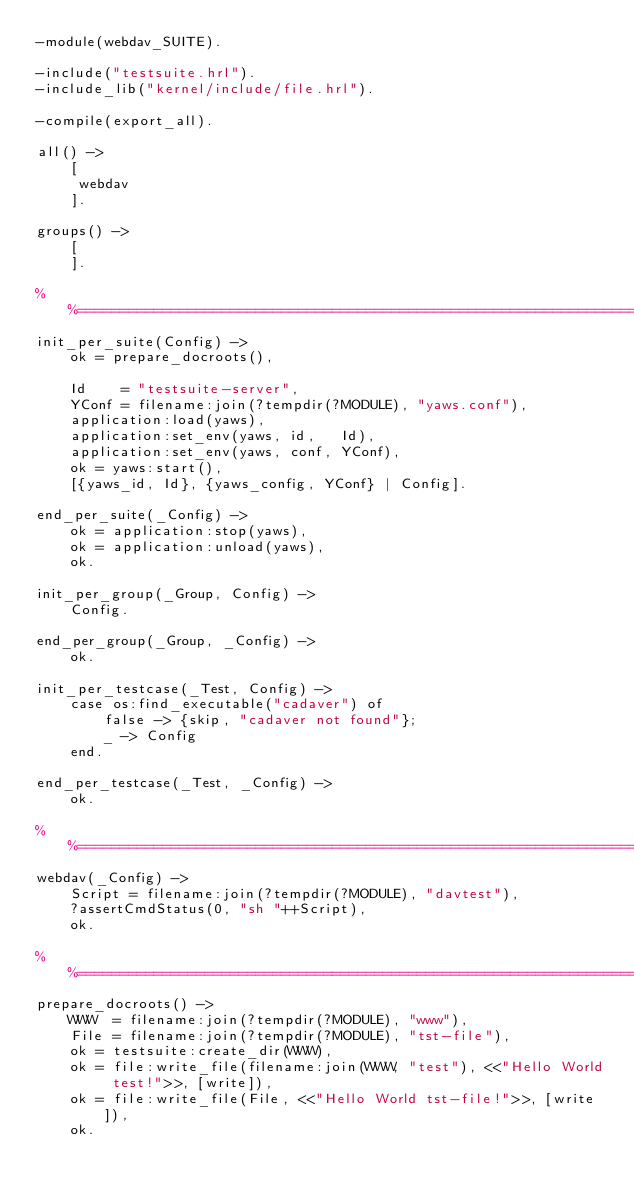Convert code to text. <code><loc_0><loc_0><loc_500><loc_500><_Erlang_>-module(webdav_SUITE).

-include("testsuite.hrl").
-include_lib("kernel/include/file.hrl").

-compile(export_all).

all() ->
    [
     webdav
    ].

groups() ->
    [
    ].

%%====================================================================
init_per_suite(Config) ->
    ok = prepare_docroots(),

    Id    = "testsuite-server",
    YConf = filename:join(?tempdir(?MODULE), "yaws.conf"),
    application:load(yaws),
    application:set_env(yaws, id,   Id),
    application:set_env(yaws, conf, YConf),
    ok = yaws:start(),
    [{yaws_id, Id}, {yaws_config, YConf} | Config].

end_per_suite(_Config) ->
    ok = application:stop(yaws),
    ok = application:unload(yaws),
    ok.

init_per_group(_Group, Config) ->
    Config.

end_per_group(_Group, _Config) ->
    ok.

init_per_testcase(_Test, Config) ->
    case os:find_executable("cadaver") of
        false -> {skip, "cadaver not found"};
        _ -> Config
    end.

end_per_testcase(_Test, _Config) ->
    ok.

%%====================================================================
webdav(_Config) ->
    Script = filename:join(?tempdir(?MODULE), "davtest"),
    ?assertCmdStatus(0, "sh "++Script),
    ok.

%%====================================================================
prepare_docroots() ->
    WWW  = filename:join(?tempdir(?MODULE), "www"),
    File = filename:join(?tempdir(?MODULE), "tst-file"),
    ok = testsuite:create_dir(WWW),
    ok = file:write_file(filename:join(WWW, "test"), <<"Hello World test!">>, [write]),
    ok = file:write_file(File, <<"Hello World tst-file!">>, [write]),
    ok.
</code> 